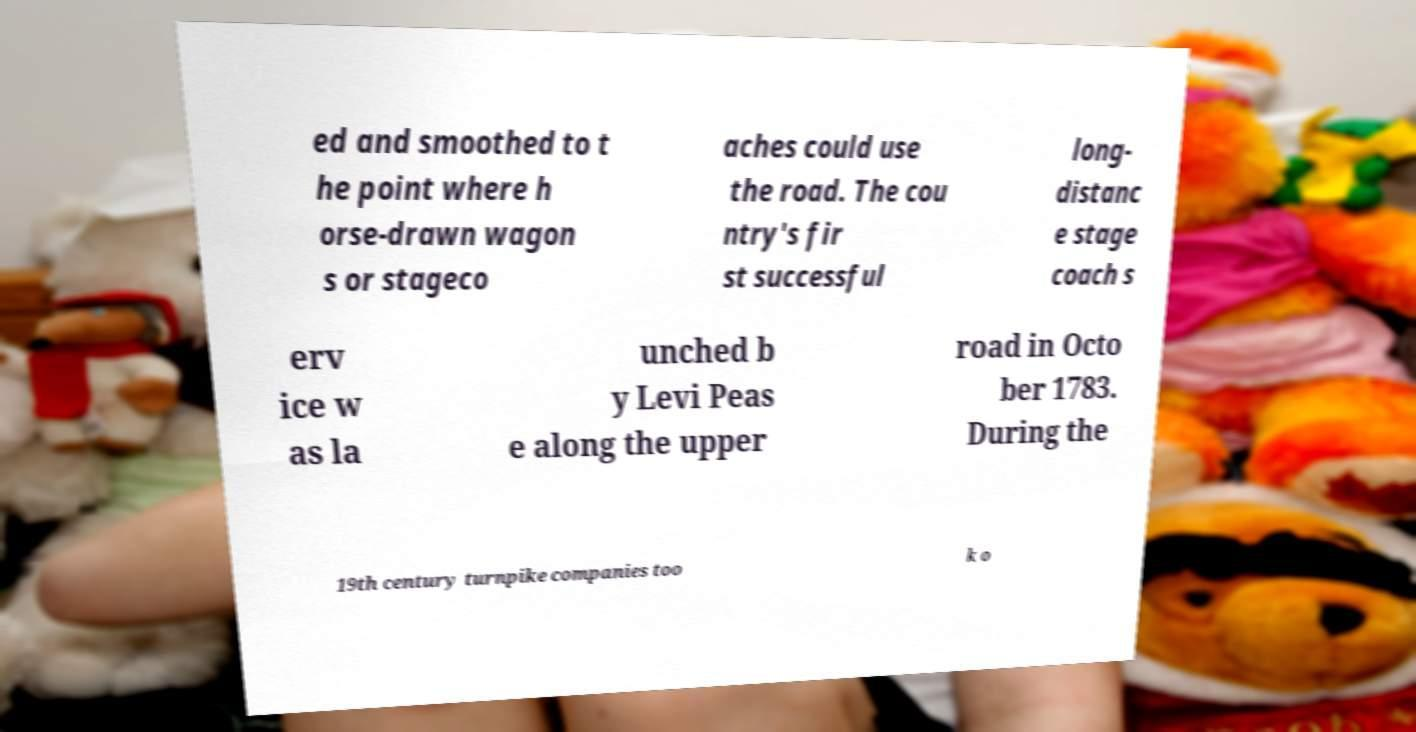Can you read and provide the text displayed in the image?This photo seems to have some interesting text. Can you extract and type it out for me? ed and smoothed to t he point where h orse-drawn wagon s or stageco aches could use the road. The cou ntry's fir st successful long- distanc e stage coach s erv ice w as la unched b y Levi Peas e along the upper road in Octo ber 1783. During the 19th century turnpike companies too k o 